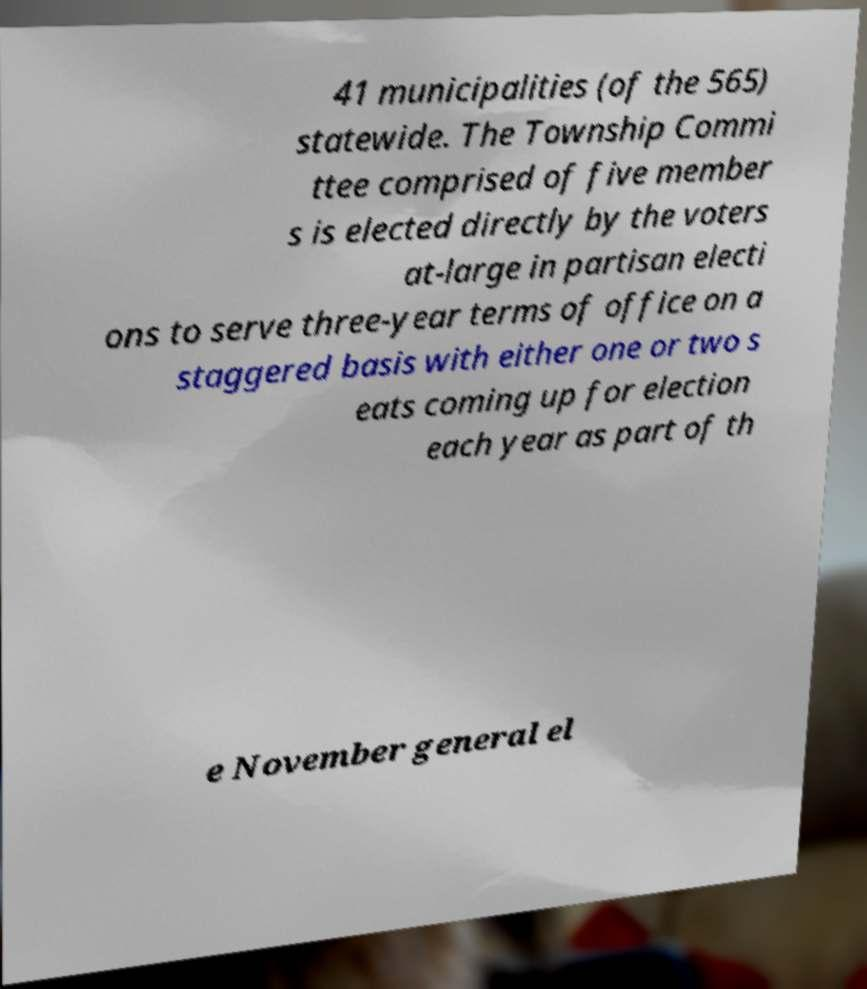Please identify and transcribe the text found in this image. 41 municipalities (of the 565) statewide. The Township Commi ttee comprised of five member s is elected directly by the voters at-large in partisan electi ons to serve three-year terms of office on a staggered basis with either one or two s eats coming up for election each year as part of th e November general el 